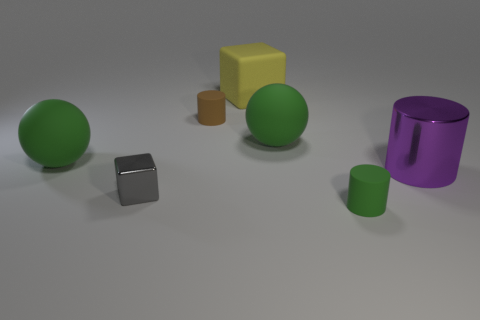What is the color of the largest spherical object in the image? The largest spherical object in the image has a vivid green hue, giving it a distinctive appearance among the other items. 